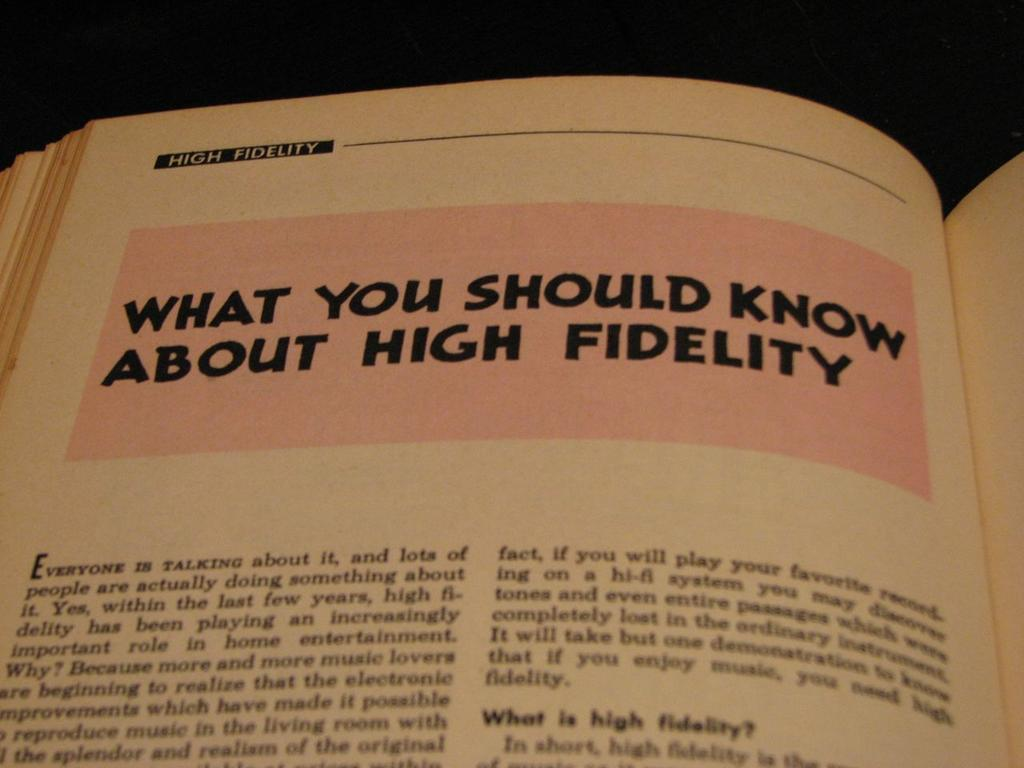<image>
Render a clear and concise summary of the photo. A book is opened to a chapter about high fidelity. 